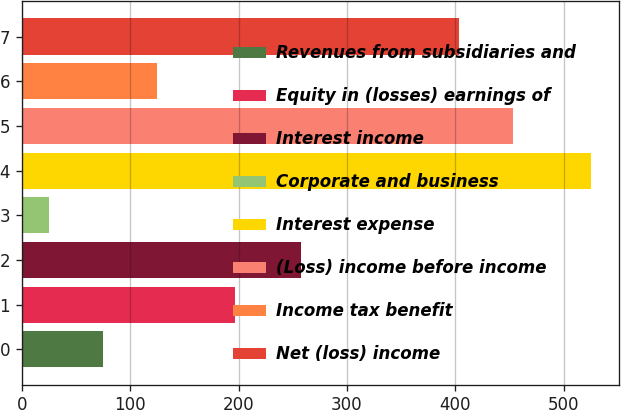<chart> <loc_0><loc_0><loc_500><loc_500><bar_chart><fcel>Revenues from subsidiaries and<fcel>Equity in (losses) earnings of<fcel>Interest income<fcel>Corporate and business<fcel>Interest expense<fcel>(Loss) income before income<fcel>Income tax benefit<fcel>Net (loss) income<nl><fcel>75<fcel>197<fcel>258<fcel>25<fcel>525<fcel>453<fcel>125<fcel>403<nl></chart> 